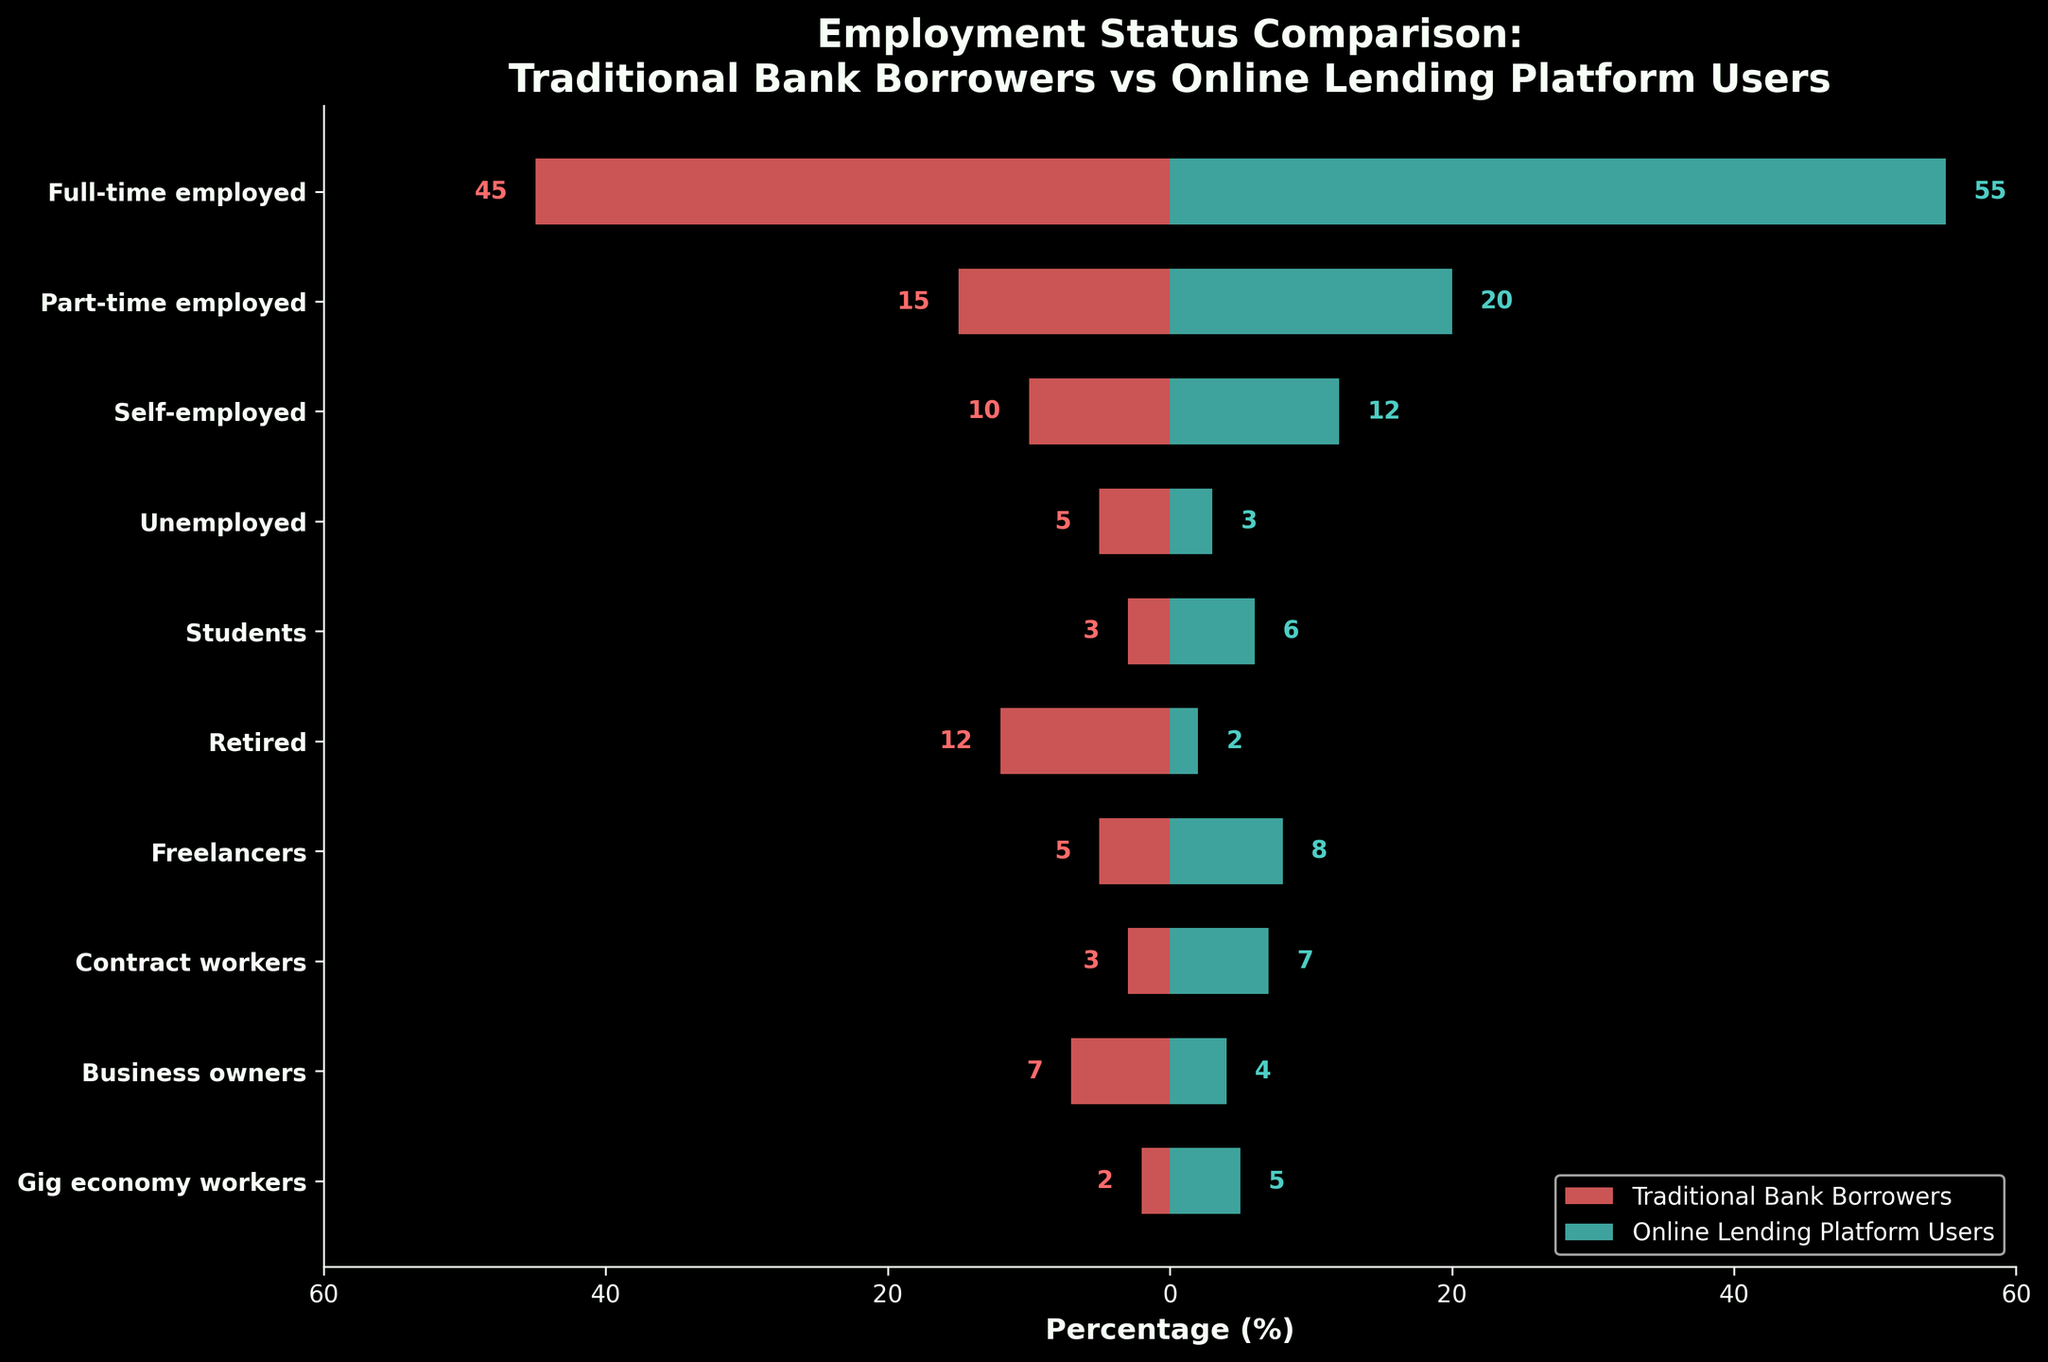what is the title of the figure? The title of a figure provides a summary of what the figure is about. By looking at the top part of the figure, we observe the text given as the title that summarizes the comparison being shown.
Answer: Employment Status Comparison: Traditional Bank Borrowers vs Online Lending Platform Users How many employment categories are compared? To determine the number of categories, count the tick labels on the y-axis of the figure. Each label represents a different employment status category.
Answer: 10 Which group has a higher percentage of full-time employed individuals? Compare the lengths of the horizontal bars corresponding to "Full-time employed" on both the Traditional Bank Borrowers and Online Lending Platform Users sides. The longer bar represents the group with a higher percentage.
Answer: Online Lending Platform Users What is the percentage of retired individuals among traditional bank borrowers? Look at the bar corresponding to the "Retired" category on the Traditional Bank Borrowers side and read the percentage value indicated next to the bar.
Answer: 12 What is the difference in percentages of part-time employed individuals between the two groups? Identify the bars corresponding to "Part-time employed" for both Traditional Bank Borrowers and Online Lending Platform Users. Calculate the absolute difference between the two percentages.
Answer: 5 Are there more unemployed individuals among traditional bank borrowers or online lending platform users? Compare the lengths of the bars for the "Unemployed" category on both the Traditional Bank Borrowers and Online Lending Platform Users sides.
Answer: Traditional Bank Borrowers Which group has a lower percentage of self-employed individuals? Compare the lengths of the bars corresponding to the "Self-employed" category on both sides. The shorter bar indicates the group with a lower percentage.
Answer: Traditional Bank Borrowers How does the percentage of gig economy workers compare between the two groups? Look at the bars corresponding to "Gig economy workers" on both sides and compare their lengths to see which group has a higher percentage.
Answer: Online Lending Platform Users What is the sum percentage of full-time and part-time employed individuals for traditional bank borrowers? Add the percentages of "Full-time employed" and "Part-time employed" bars on the side of Traditional Bank Borrowers.
Answer: 60 How many more students are there in online lending platform users compared to traditional bank borrowers? Look at the student bars for both groups, calculate the difference by subtracting the percentage of students for Traditional Bank Borrowers from the percentage of students for Online Lending Platform Users.
Answer: 3 